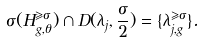<formula> <loc_0><loc_0><loc_500><loc_500>\sigma ( H _ { g , \theta } ^ { \geqslant \sigma } ) \cap D ( \lambda _ { j } , \frac { \sigma } { 2 } ) = \{ \lambda _ { j , g } ^ { \geqslant \sigma } \} .</formula> 